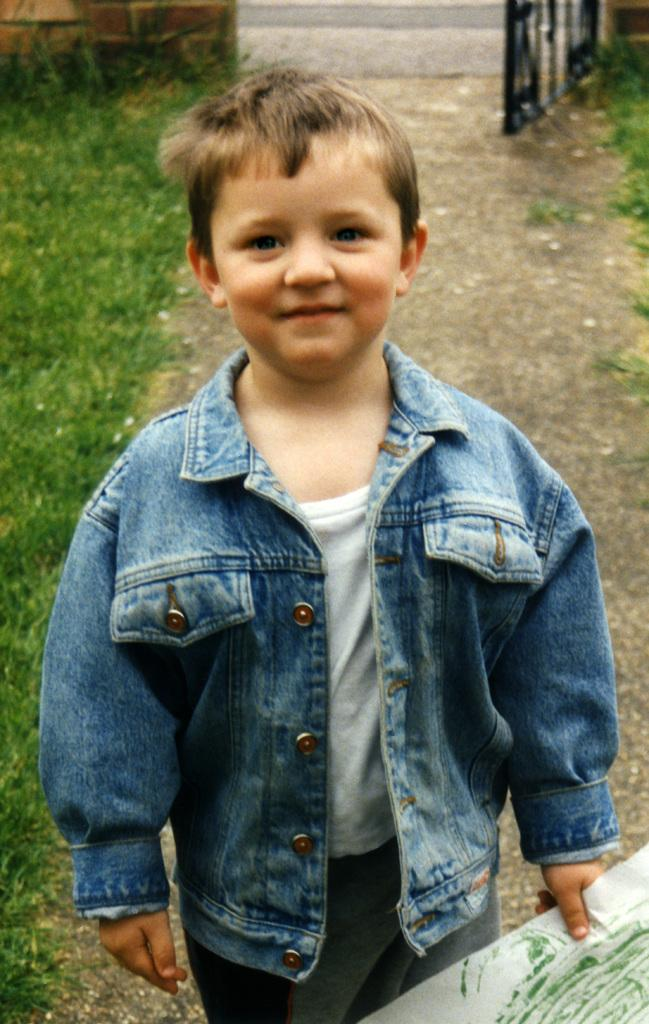Who is present in the image? There is a boy in the image. What is the boy wearing? The boy is wearing a jacket. What is the boy holding in the image? The boy is holding a paper. What can be seen in the background of the image? There is a gate in the background of the image. Is the boy wearing a scarf in the image? No, the boy is wearing a jacket, not a scarf, in the image. What type of art can be seen on the gate in the background? There is no art visible on the gate in the background of the image. 